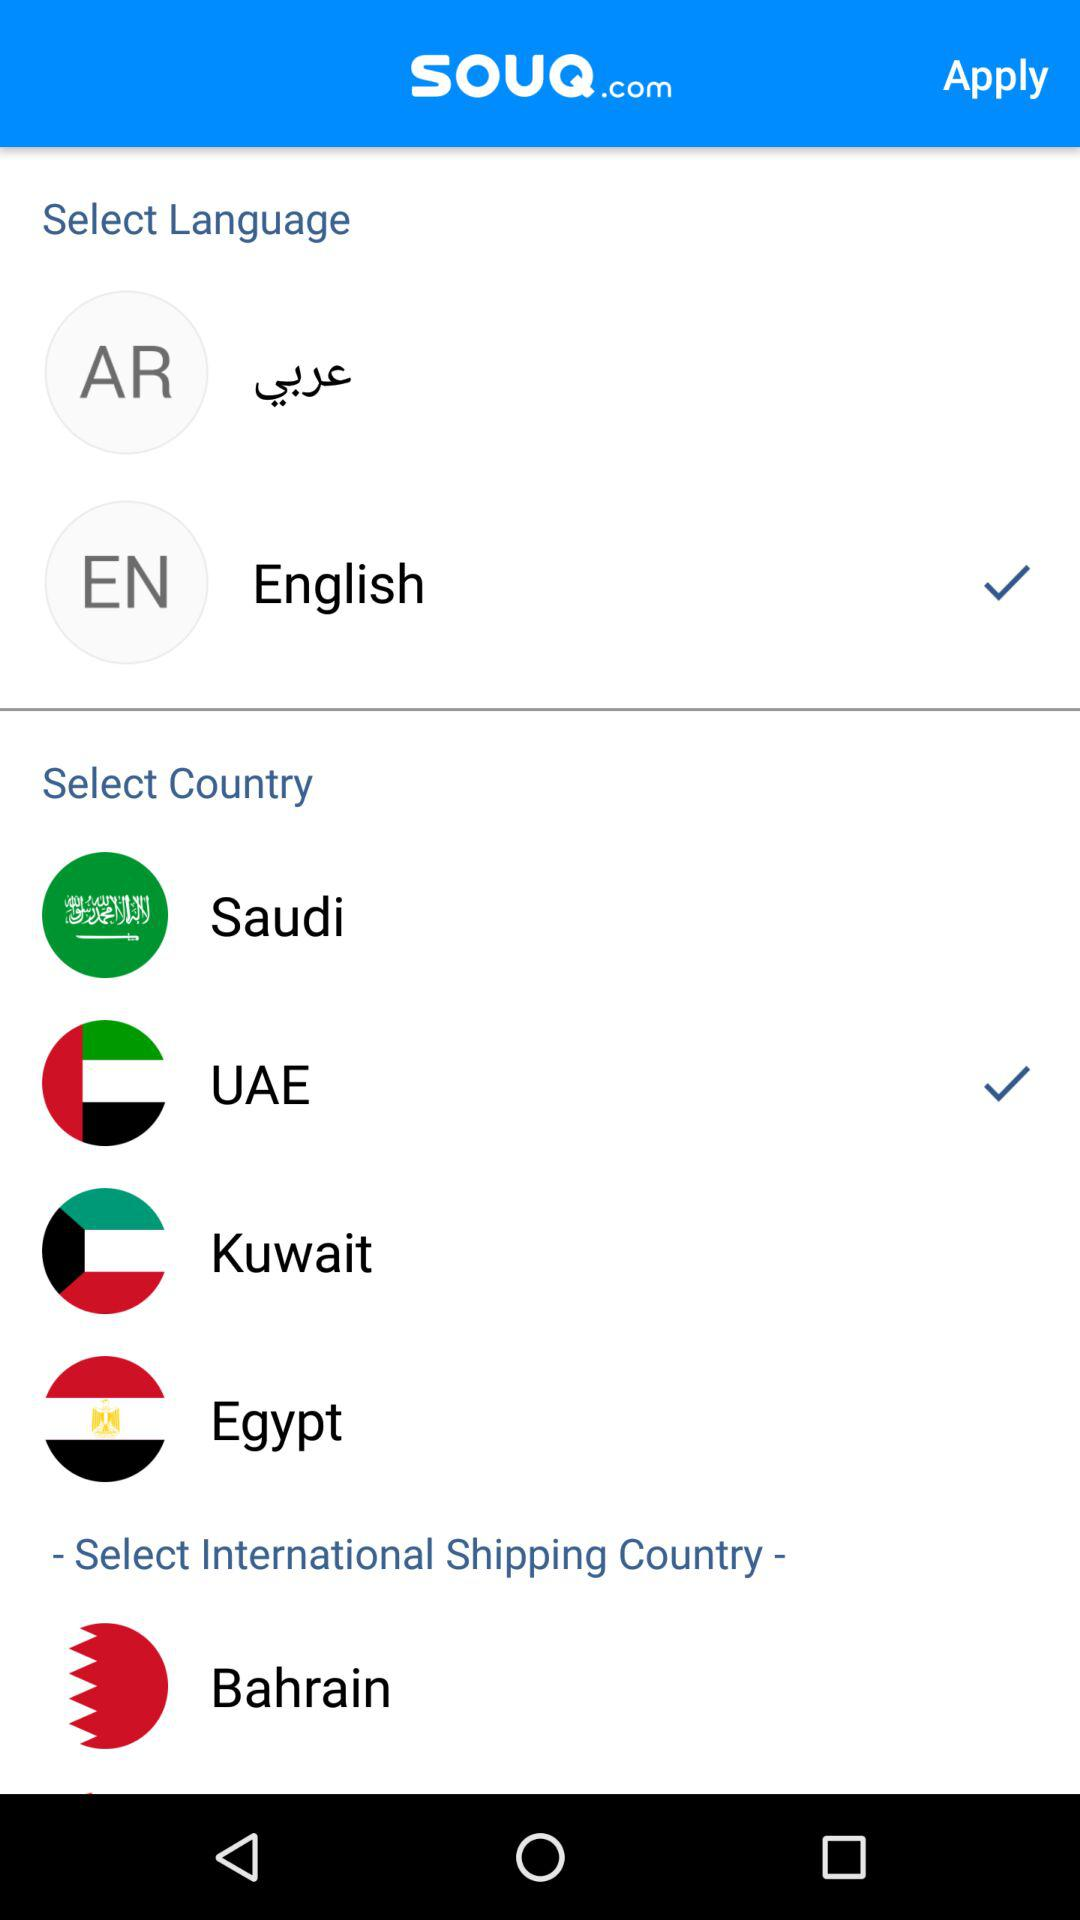What is the selected country? The selected country is Saudi Arabia. 